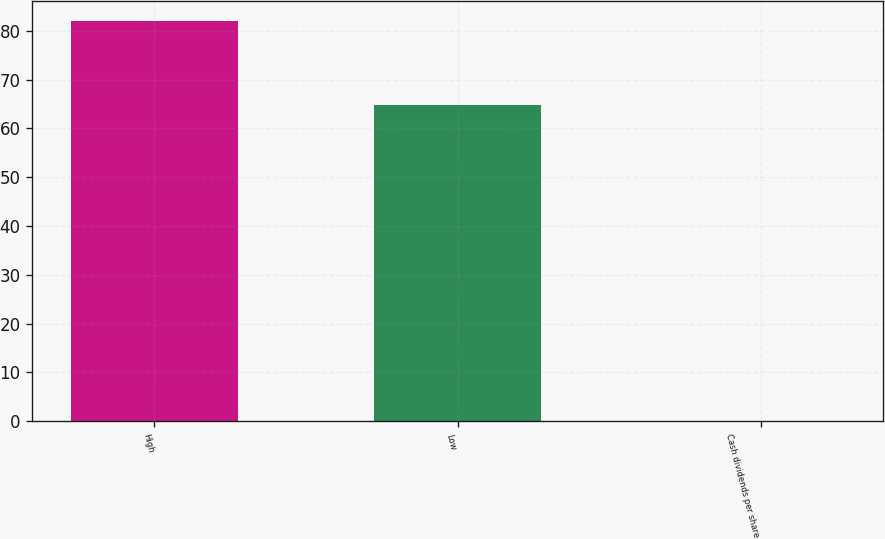<chart> <loc_0><loc_0><loc_500><loc_500><bar_chart><fcel>High<fcel>Low<fcel>Cash dividends per share<nl><fcel>82.03<fcel>64.87<fcel>0.13<nl></chart> 